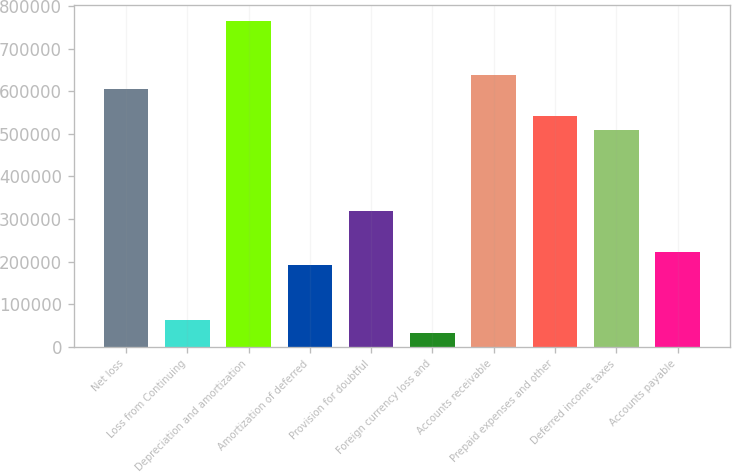Convert chart. <chart><loc_0><loc_0><loc_500><loc_500><bar_chart><fcel>Net loss<fcel>Loss from Continuing<fcel>Depreciation and amortization<fcel>Amortization of deferred<fcel>Provision for doubtful<fcel>Foreign currency loss and<fcel>Accounts receivable<fcel>Prepaid expenses and other<fcel>Deferred income taxes<fcel>Accounts payable<nl><fcel>605938<fcel>63828.6<fcel>765382<fcel>191384<fcel>318939<fcel>31939.8<fcel>637827<fcel>542161<fcel>510272<fcel>223273<nl></chart> 